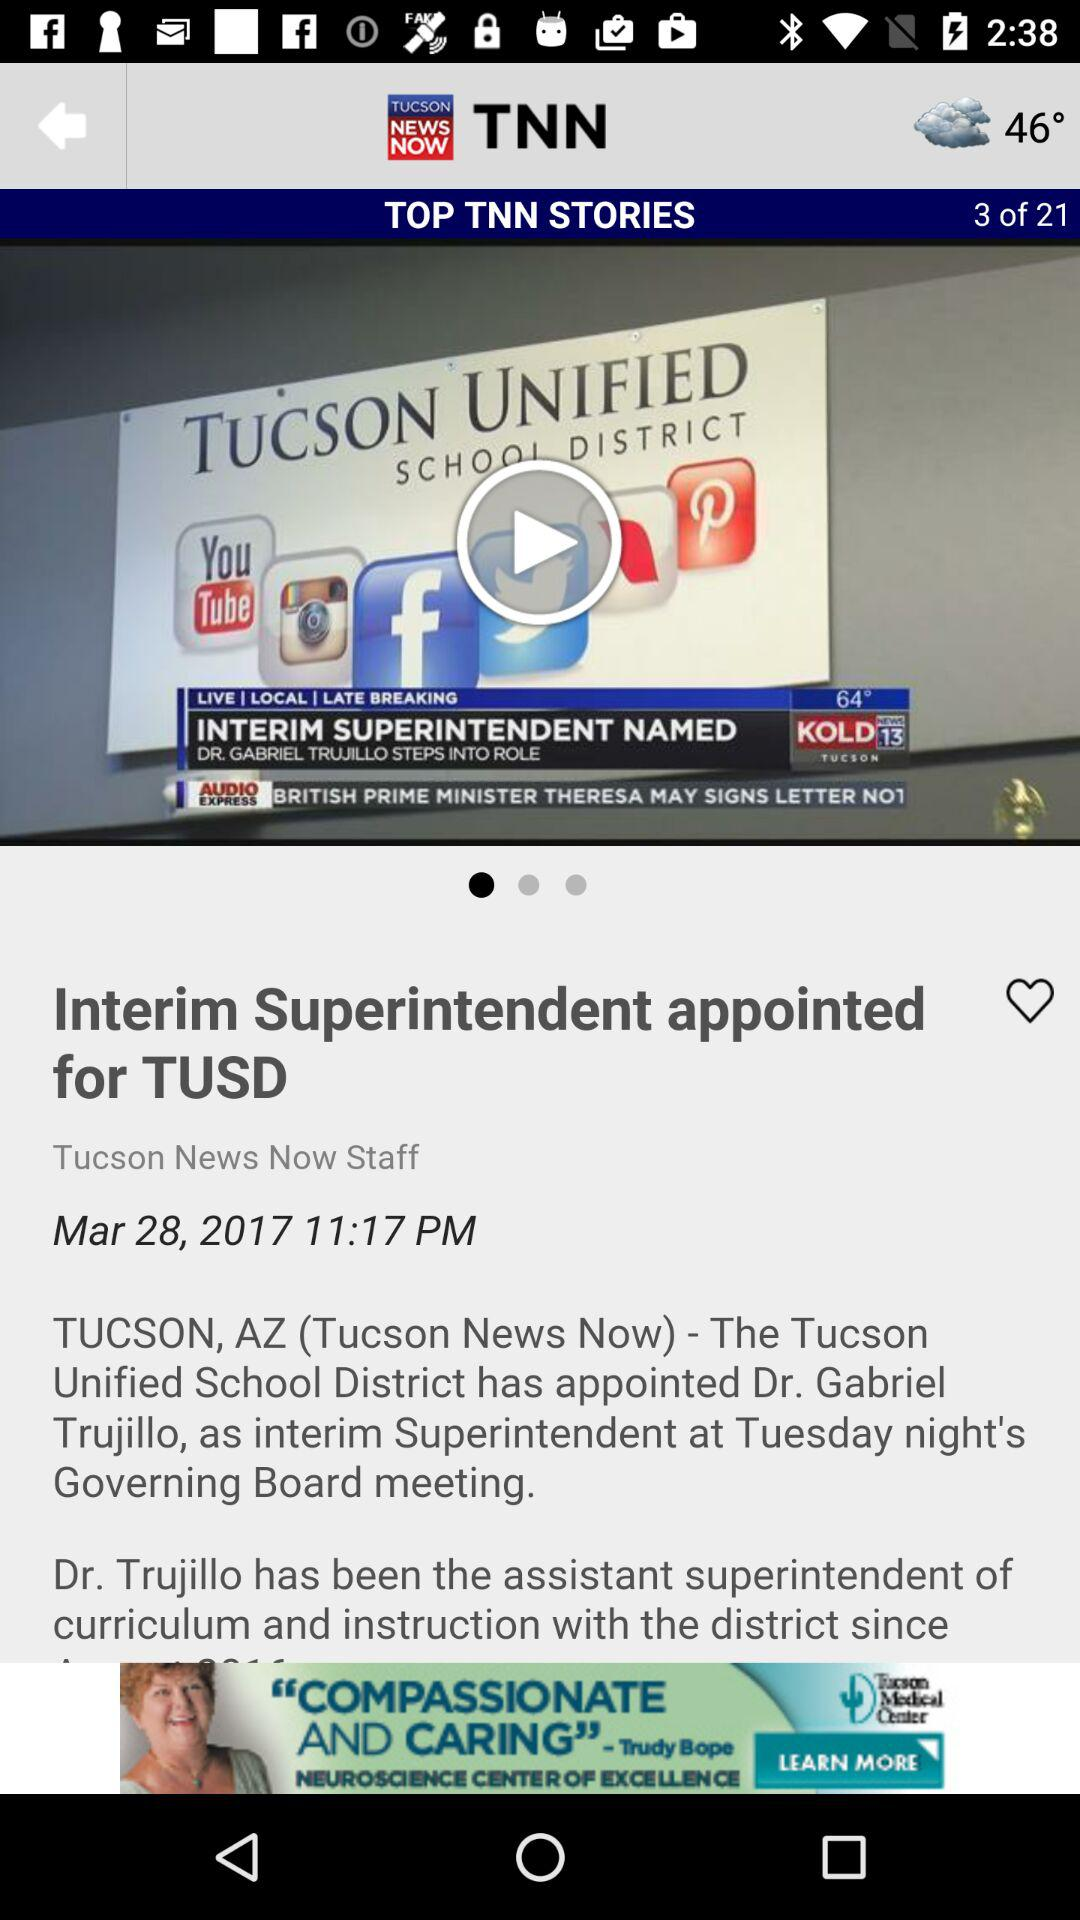How many "TOP TNN STORIES" are there? There are 21 "TOP TNN STORIES". 